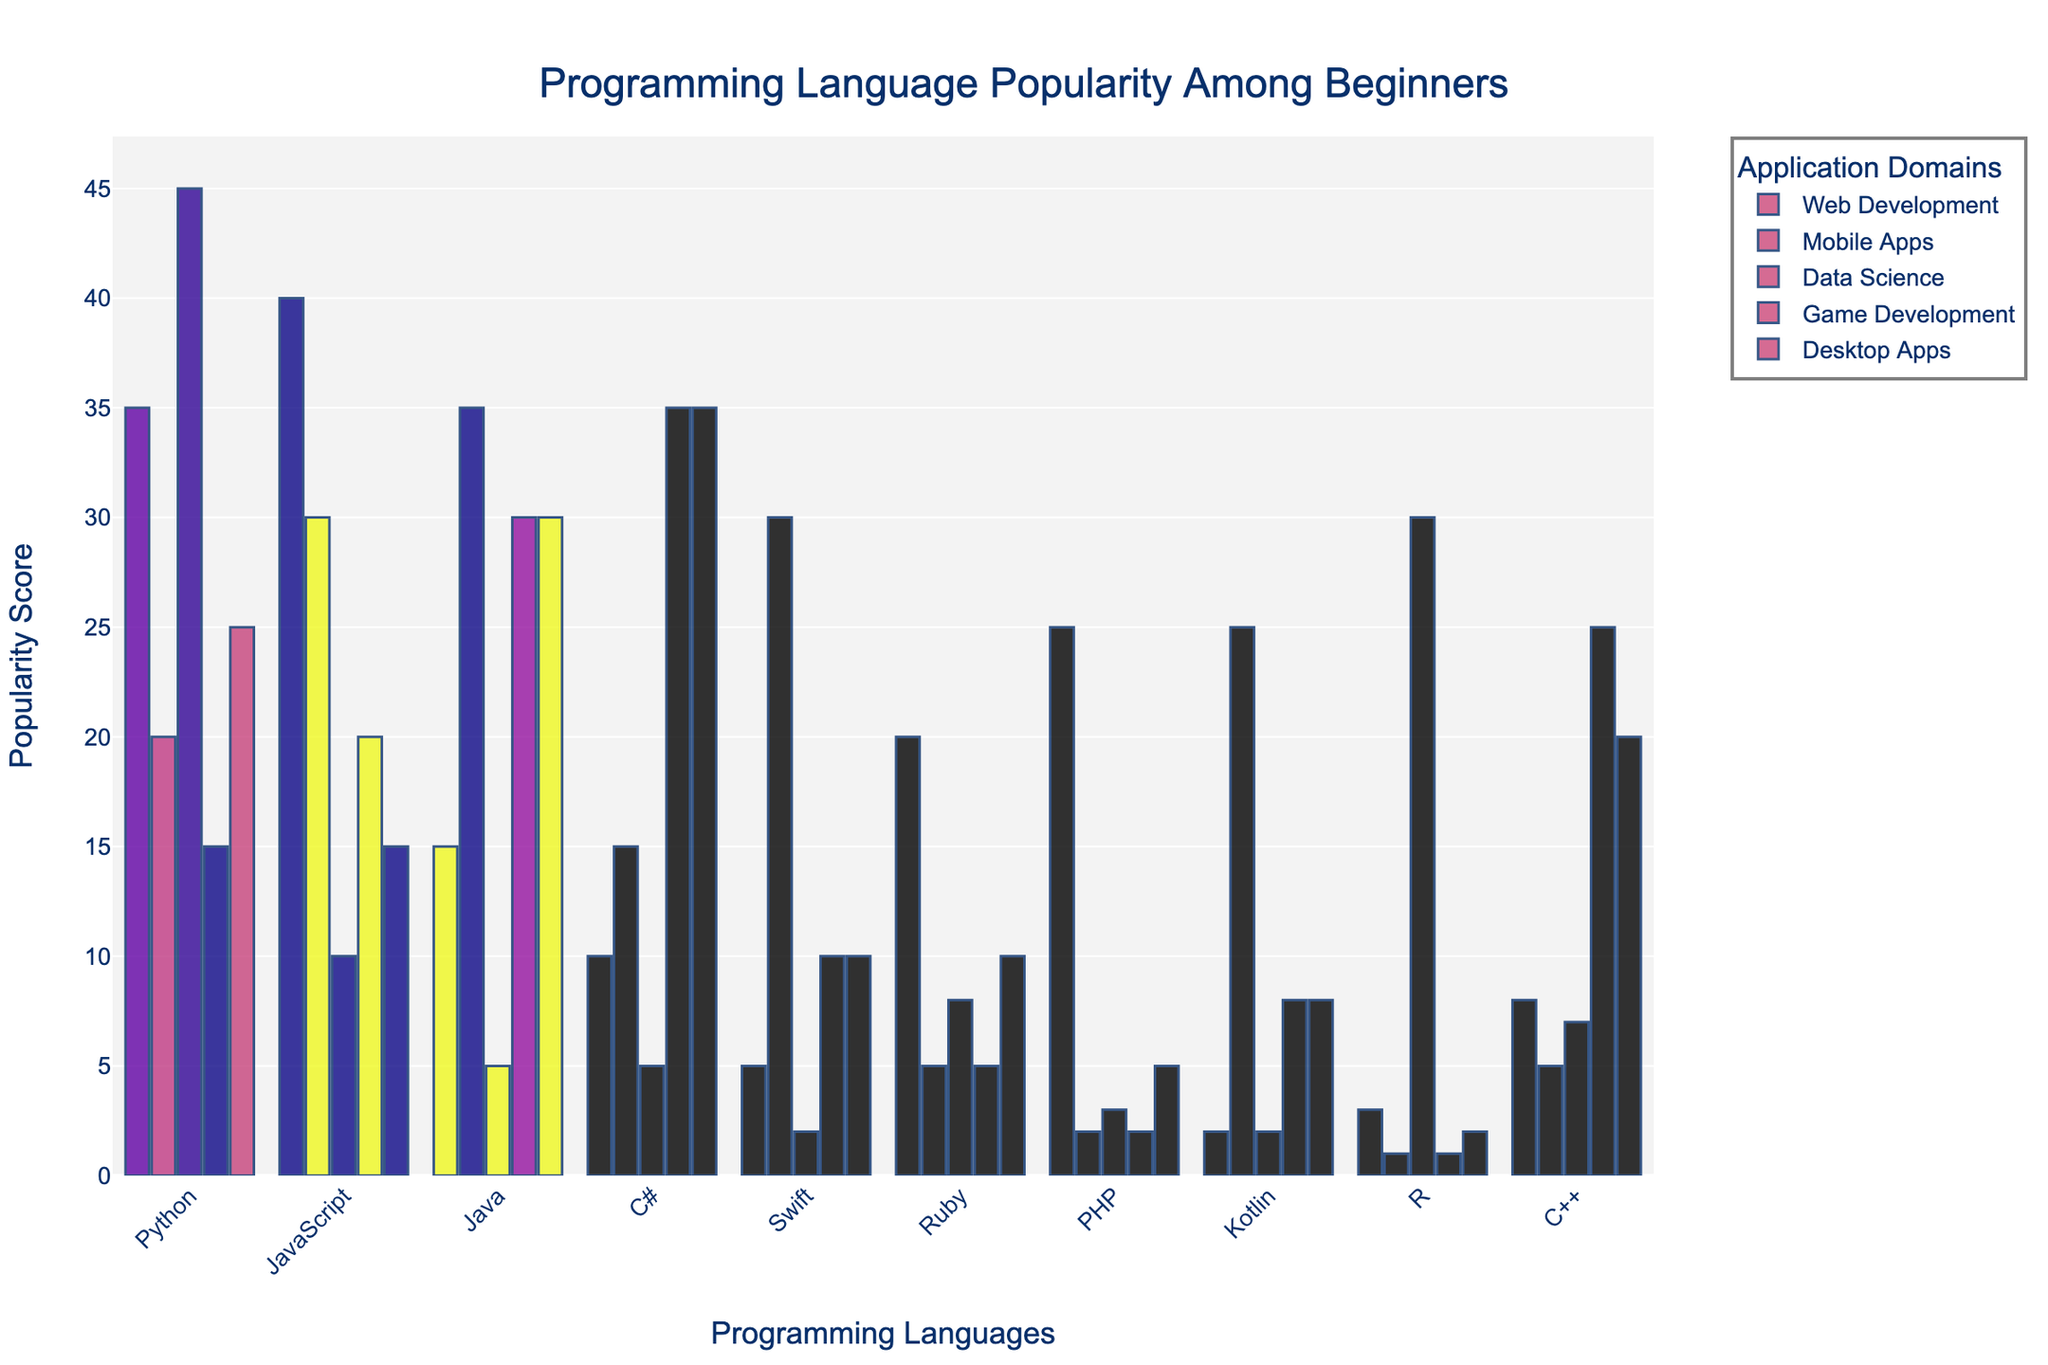What's the most popular programming language for web development among beginners? From the figure, the bar corresponding to JavaScript has the highest value in the web development category compared to other languages.
Answer: JavaScript Which programming language is equally popular for game development and desktop apps? C# is used equally in game development and desktop apps, both having the same height of the bars in these categories.
Answer: C# What's the combined popularity score of Python in web development and data science? From the figure, Python has a score of 35 in web development and 45 in data science. Adding these two values together gives 35 + 45 = 80.
Answer: 80 Which programming languages have a higher popularity score for data science than for mobile apps? Comparing the height of the bars for data science and mobile apps, the languages that meet this criterion are Python, R, and Ruby.
Answer: Python, R, Ruby Who is more popular for mobile apps, Java or Swift? The height of the bar for Java in mobile apps is higher than that for Swift.
Answer: Java What's the total popularity score for PHP across all application domains? Summing up the values for PHP across web development, mobile apps, data science, game development, and desktop apps (25 + 2 + 3 + 2 + 5) results in a total score of 37.
Answer: 37 For which application domain is Python the least popular? Looking at the bars for Python, the lowest value (least height) is in the game development category.
Answer: Game Development Which language shows the least popularity for desktop apps? From the chart, PHP has the smallest bar in the desktop apps category.
Answer: PHP What is the difference in popularity between Java's mobile apps and web development scores? Java's popularity score in mobile apps is 35, and in web development, it is 15. The difference is 35 - 15 = 20.
Answer: 20 Which programming language is most consistently popular across different domains? Considering the bar heights across all domains, Java seems to have relatively equal heights, indicating consistent popularity.
Answer: Java 